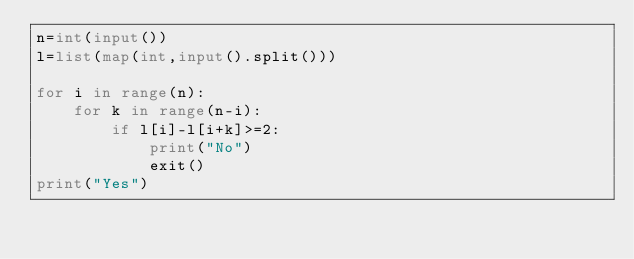Convert code to text. <code><loc_0><loc_0><loc_500><loc_500><_Python_>n=int(input())
l=list(map(int,input().split()))

for i in range(n):
    for k in range(n-i):
        if l[i]-l[i+k]>=2:
            print("No")
            exit()
print("Yes")
</code> 